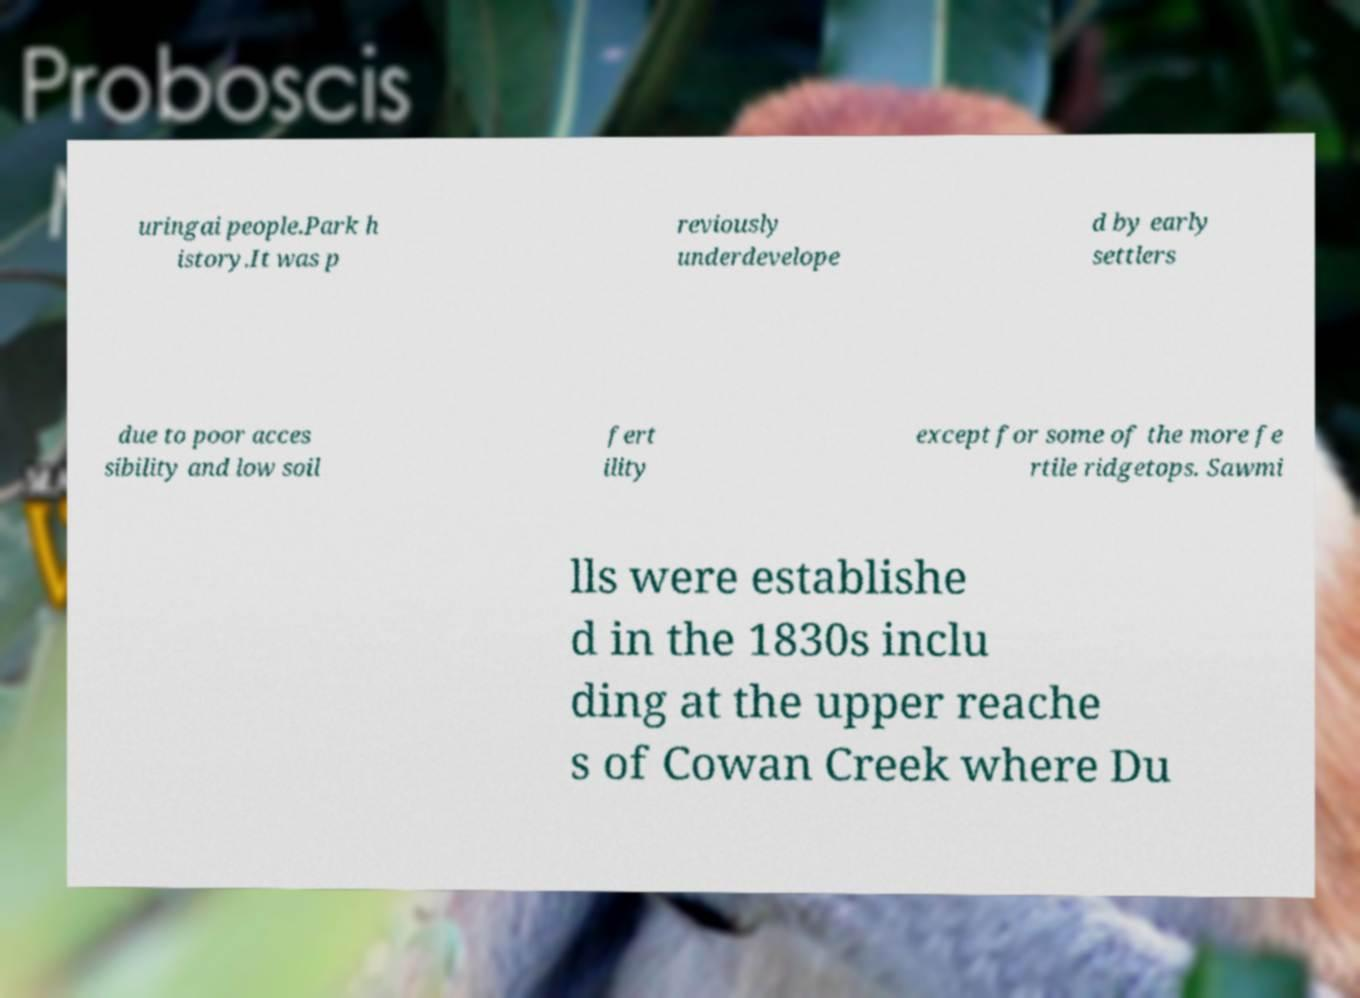What messages or text are displayed in this image? I need them in a readable, typed format. uringai people.Park h istory.It was p reviously underdevelope d by early settlers due to poor acces sibility and low soil fert ility except for some of the more fe rtile ridgetops. Sawmi lls were establishe d in the 1830s inclu ding at the upper reache s of Cowan Creek where Du 